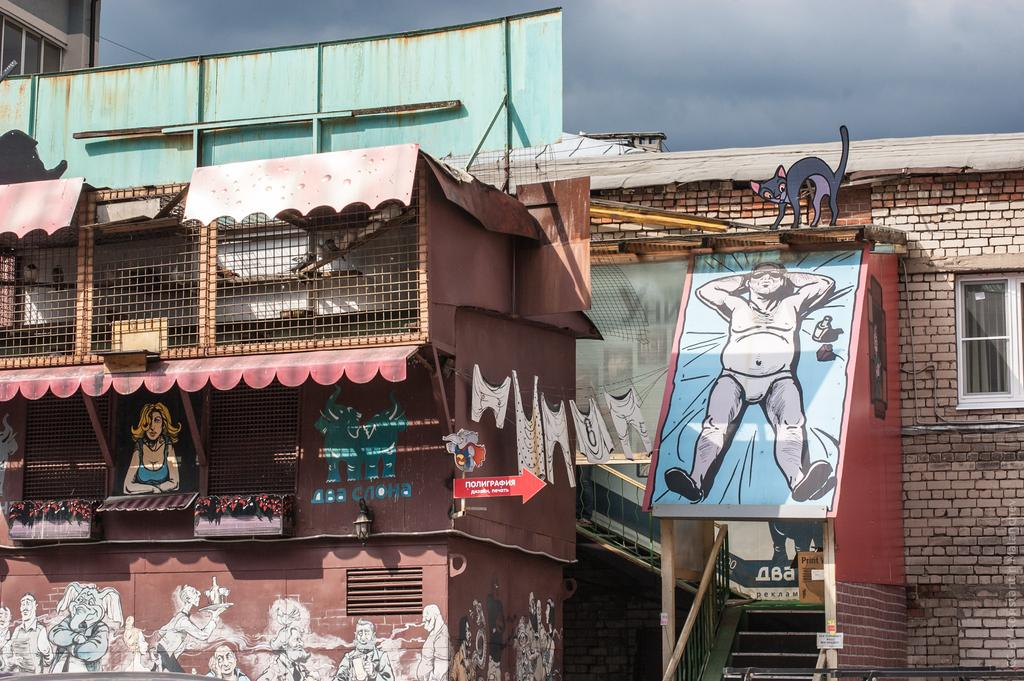What type of artwork can be seen on the wall in the image? There are paintings on the wall in the image. What material are the rods made of in the image? There are metal rods in the image. What is the large sign in the image called? There is a hoarding in the image. What type of structures are visible in the image? There are houses in the image. What type of prose is written on the hoarding in the image? There is no prose visible on the hoarding in the image; it is a large sign with an advertisement or message. What type of treatment is being administered to the metal rods in the image? There is no treatment being administered to the metal rods in the image; they are simply present as part of the scene. 